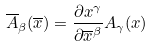Convert formula to latex. <formula><loc_0><loc_0><loc_500><loc_500>\overline { A } _ { \beta } ( \overline { x } ) = \frac { \partial x ^ { \gamma } } { \partial \overline { x } ^ { \beta } } A _ { \gamma } ( x )</formula> 